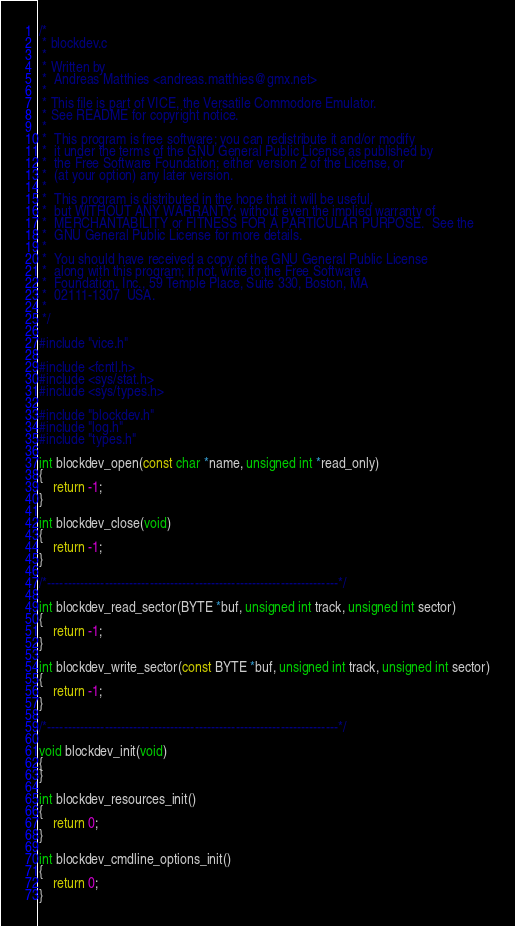<code> <loc_0><loc_0><loc_500><loc_500><_C_>/*
 * blockdev.c
 *
 * Written by
 *  Andreas Matthies <andreas.matthies@gmx.net>
 *
 * This file is part of VICE, the Versatile Commodore Emulator.
 * See README for copyright notice.
 *
 *  This program is free software; you can redistribute it and/or modify
 *  it under the terms of the GNU General Public License as published by
 *  the Free Software Foundation; either version 2 of the License, or
 *  (at your option) any later version.
 *
 *  This program is distributed in the hope that it will be useful,
 *  but WITHOUT ANY WARRANTY; without even the implied warranty of
 *  MERCHANTABILITY or FITNESS FOR A PARTICULAR PURPOSE.  See the
 *  GNU General Public License for more details.
 *
 *  You should have received a copy of the GNU General Public License
 *  along with this program; if not, write to the Free Software
 *  Foundation, Inc., 59 Temple Place, Suite 330, Boston, MA
 *  02111-1307  USA.
 *
 */

#include "vice.h"

#include <fcntl.h>
#include <sys/stat.h>
#include <sys/types.h>

#include "blockdev.h"
#include "log.h"
#include "types.h"

int blockdev_open(const char *name, unsigned int *read_only)
{
    return -1;
}

int blockdev_close(void)
{
    return -1;
}

/*-----------------------------------------------------------------------*/

int blockdev_read_sector(BYTE *buf, unsigned int track, unsigned int sector)
{
    return -1;
}

int blockdev_write_sector(const BYTE *buf, unsigned int track, unsigned int sector)
{
    return -1;
}

/*-----------------------------------------------------------------------*/

void blockdev_init(void)
{
}

int blockdev_resources_init()
{
    return 0;
}

int blockdev_cmdline_options_init()
{
    return 0;
}
</code> 